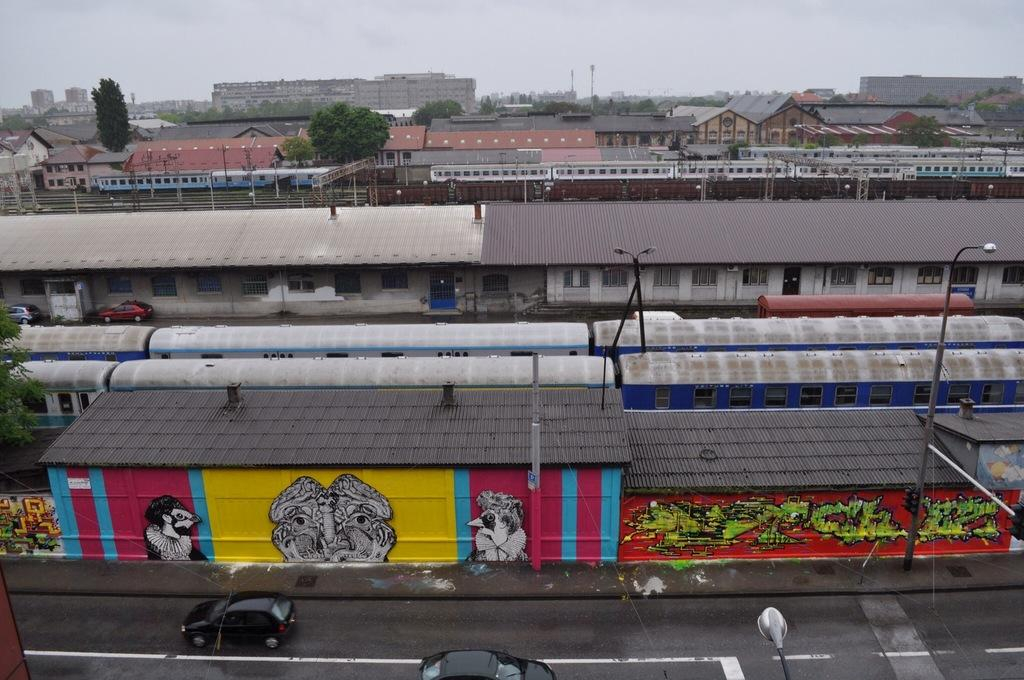What type of structures can be seen in the image? There are houses in the image. What else is present in the image besides houses? There are vehicles, pole lights, trees, and other objects in the image. Can you describe the lighting in the image? Pole lights are present in the image. What is visible in the background of the image? The sky is visible in the background of the image. What type of dock can be seen in the image? There is no dock present in the image. What committee is responsible for the maintenance of the houses in the image? There is no information about a committee responsible for the maintenance of the houses in the image. 